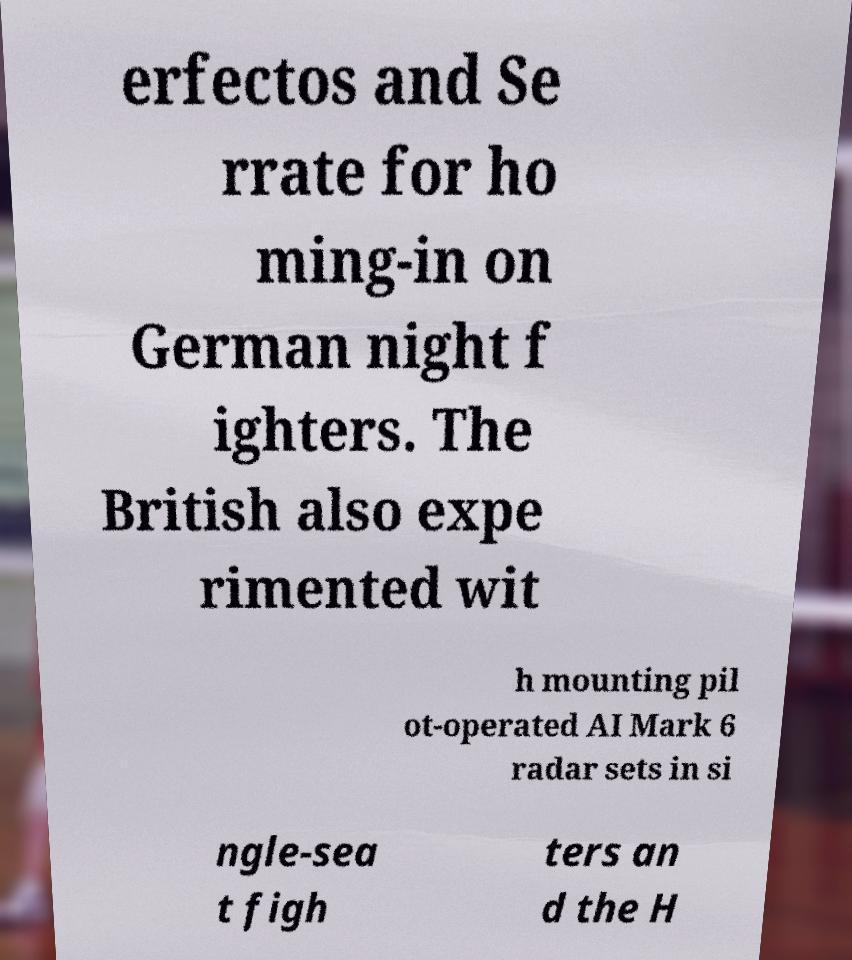Could you extract and type out the text from this image? erfectos and Se rrate for ho ming-in on German night f ighters. The British also expe rimented wit h mounting pil ot-operated AI Mark 6 radar sets in si ngle-sea t figh ters an d the H 